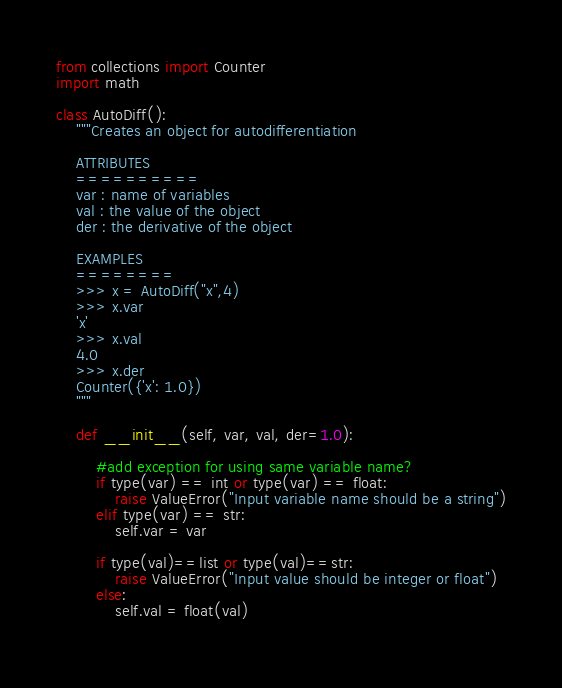Convert code to text. <code><loc_0><loc_0><loc_500><loc_500><_Python_>from collections import Counter
import math

class AutoDiff():
    """Creates an object for autodifferentiation

    ATTRIBUTES
    ==========
    var : name of variables
    val : the value of the object
    der : the derivative of the object

    EXAMPLES
    ========
    >>> x = AutoDiff("x",4)
    >>> x.var
    'x'
    >>> x.val
    4.0
    >>> x.der
    Counter({'x': 1.0})
    """

    def __init__(self, var, val, der=1.0):

        #add exception for using same variable name?
        if type(var) == int or type(var) == float:
            raise ValueError("Input variable name should be a string")
        elif type(var) == str:
            self.var = var

        if type(val)==list or type(val)==str:
            raise ValueError("Input value should be integer or float")
        else:
            self.val = float(val)
        </code> 